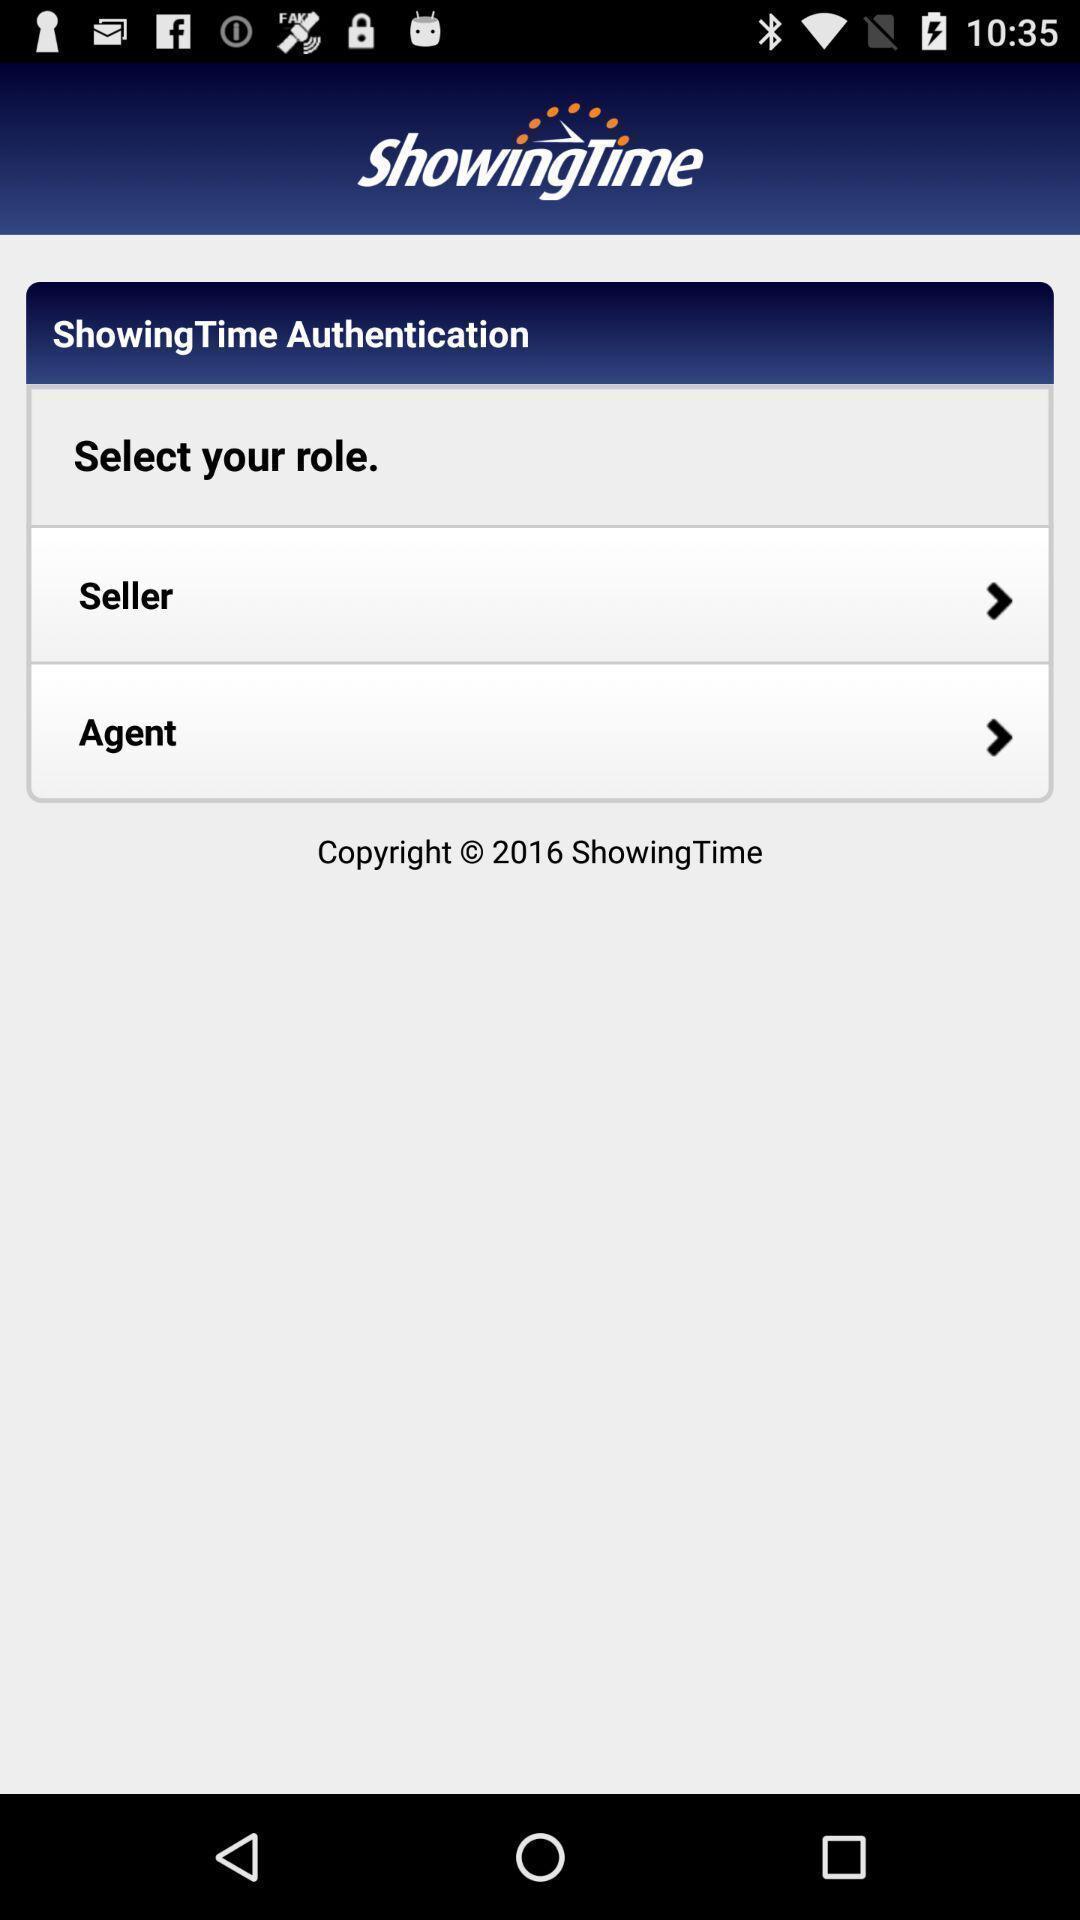Describe this image in words. Two parameters of a property finding and selling app. 